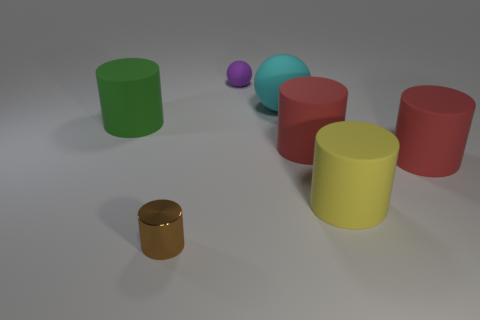How many big matte objects are both in front of the green cylinder and left of the metal object?
Give a very brief answer. 0. How many matte cylinders are to the left of the cyan sphere?
Make the answer very short. 1. Are there any green rubber things that have the same shape as the small metallic object?
Offer a very short reply. Yes. There is a yellow thing; does it have the same shape as the tiny thing that is in front of the small purple ball?
Your answer should be very brief. Yes. What number of blocks are brown things or tiny purple rubber things?
Give a very brief answer. 0. What shape is the red matte thing that is left of the large yellow cylinder?
Provide a succinct answer. Cylinder. What number of brown cubes are the same material as the big yellow cylinder?
Your answer should be compact. 0. Is the number of tiny brown metallic cylinders that are behind the brown metal cylinder less than the number of yellow rubber cylinders?
Your answer should be very brief. Yes. There is a sphere on the right side of the purple rubber thing behind the brown metal cylinder; what size is it?
Your response must be concise. Large. Does the shiny cylinder have the same color as the big object left of the brown metal object?
Offer a very short reply. No. 